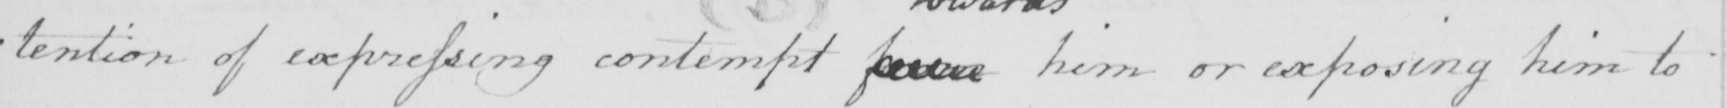What is written in this line of handwriting? : tention of expressing contempt from him or exposing him to 